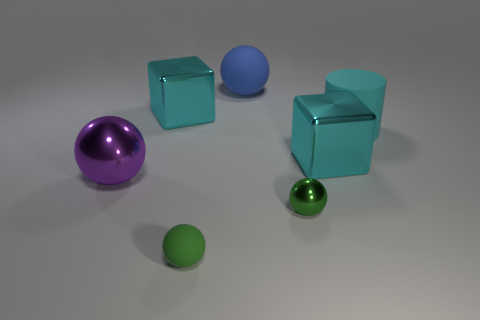There is a tiny thing that is the same color as the small metal ball; what is its material?
Give a very brief answer. Rubber. What number of other things are there of the same color as the tiny metallic thing?
Your answer should be compact. 1. There is a green metallic ball; are there any large cyan rubber objects in front of it?
Your answer should be very brief. No. What number of things are either blue matte balls that are behind the large cyan matte object or green things that are on the left side of the big rubber ball?
Give a very brief answer. 2. What number of big matte cylinders have the same color as the big matte ball?
Your response must be concise. 0. There is another big thing that is the same shape as the blue thing; what is its color?
Provide a short and direct response. Purple. There is a large thing that is behind the cyan rubber cylinder and on the left side of the tiny matte ball; what shape is it?
Keep it short and to the point. Cube. Are there more cyan cubes than tiny metal cubes?
Offer a very short reply. Yes. What is the material of the blue object?
Make the answer very short. Rubber. Is there anything else that is the same size as the cylinder?
Make the answer very short. Yes. 